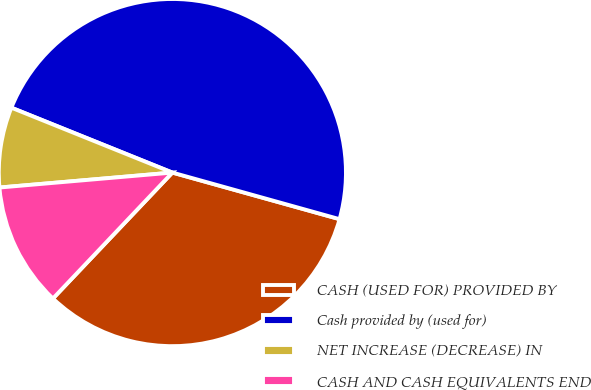Convert chart. <chart><loc_0><loc_0><loc_500><loc_500><pie_chart><fcel>CASH (USED FOR) PROVIDED BY<fcel>Cash provided by (used for)<fcel>NET INCREASE (DECREASE) IN<fcel>CASH AND CASH EQUIVALENTS END<nl><fcel>32.75%<fcel>48.23%<fcel>7.47%<fcel>11.55%<nl></chart> 